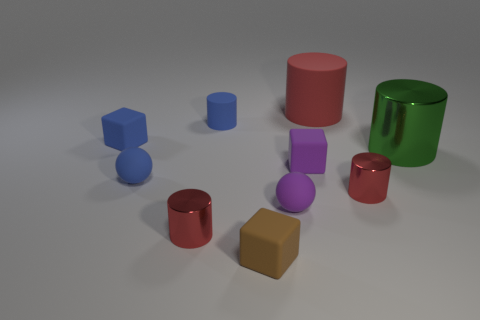Subtract all cyan cubes. How many red cylinders are left? 3 Subtract 1 cylinders. How many cylinders are left? 4 Subtract all small blue cylinders. How many cylinders are left? 4 Subtract all green cylinders. How many cylinders are left? 4 Subtract all cyan cylinders. Subtract all cyan balls. How many cylinders are left? 5 Subtract all blocks. How many objects are left? 7 Add 2 tiny blue matte spheres. How many tiny blue matte spheres exist? 3 Subtract 0 yellow cylinders. How many objects are left? 10 Subtract all yellow matte blocks. Subtract all purple cubes. How many objects are left? 9 Add 9 tiny blue cylinders. How many tiny blue cylinders are left? 10 